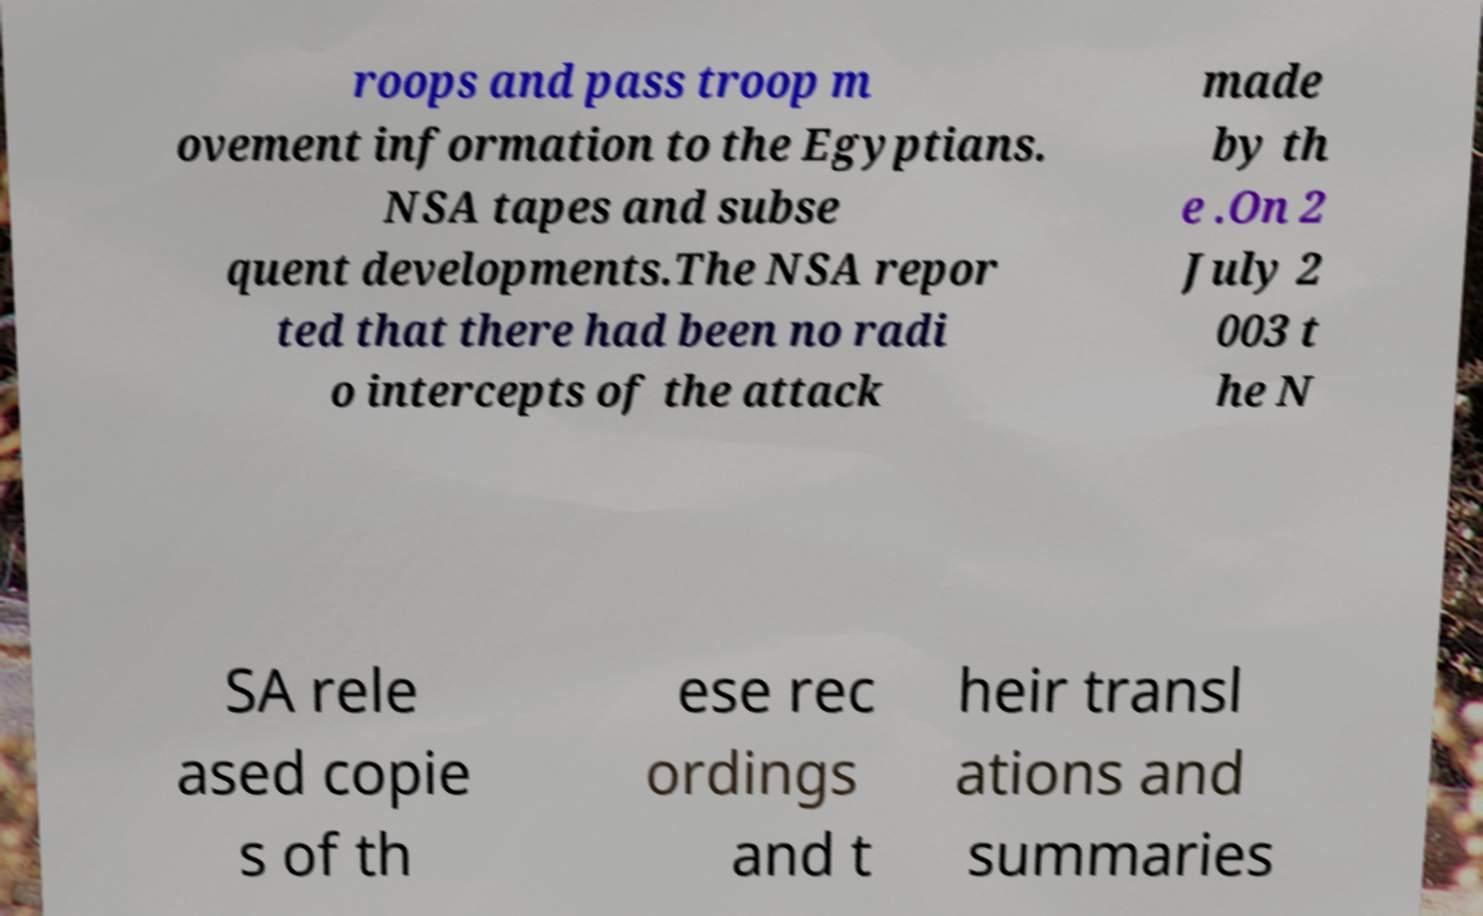Could you extract and type out the text from this image? roops and pass troop m ovement information to the Egyptians. NSA tapes and subse quent developments.The NSA repor ted that there had been no radi o intercepts of the attack made by th e .On 2 July 2 003 t he N SA rele ased copie s of th ese rec ordings and t heir transl ations and summaries 